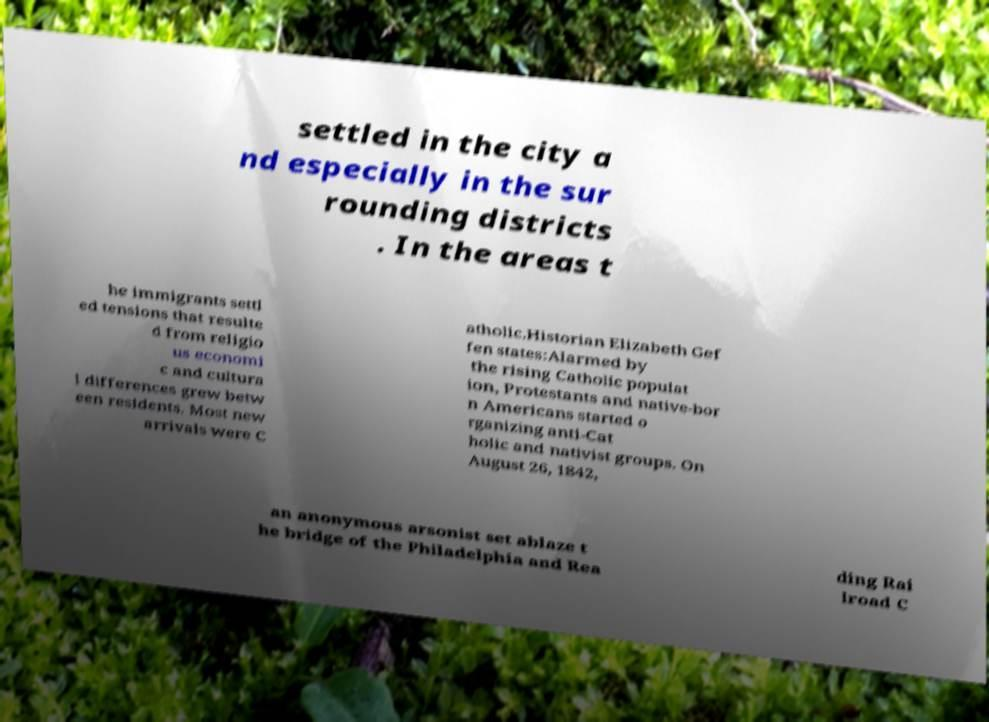Please read and relay the text visible in this image. What does it say? settled in the city a nd especially in the sur rounding districts . In the areas t he immigrants settl ed tensions that resulte d from religio us economi c and cultura l differences grew betw een residents. Most new arrivals were C atholic.Historian Elizabeth Gef fen states:Alarmed by the rising Catholic populat ion, Protestants and native-bor n Americans started o rganizing anti-Cat holic and nativist groups. On August 26, 1842, an anonymous arsonist set ablaze t he bridge of the Philadelphia and Rea ding Rai lroad C 